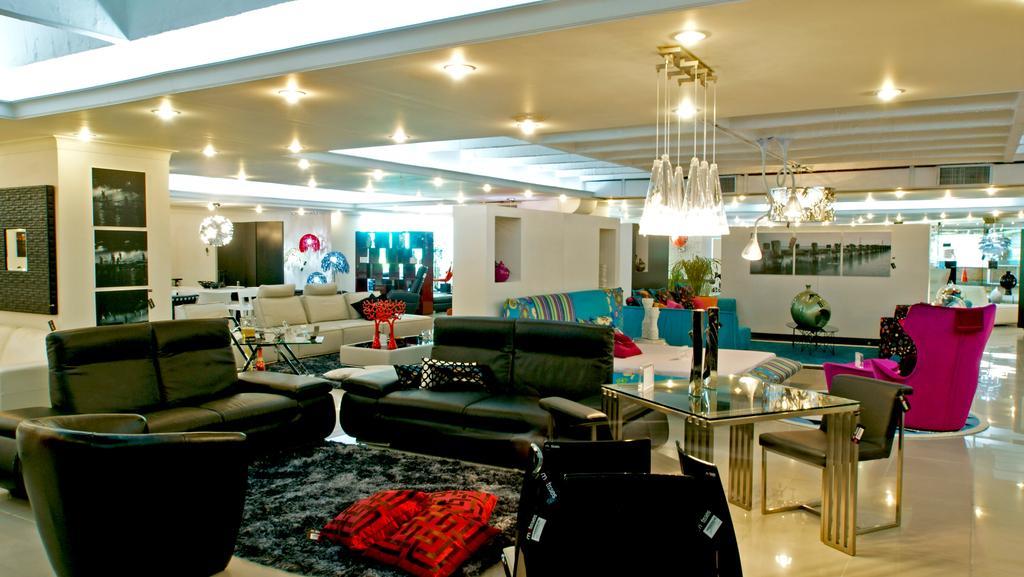In one or two sentences, can you explain what this image depicts? Lights are attached to ceiling. Here we can able to see couches, floor with carpet. On this carpet there are pillows. On this table there is a stand. Posters on wall. Far there is a plant. On this table there are things. 